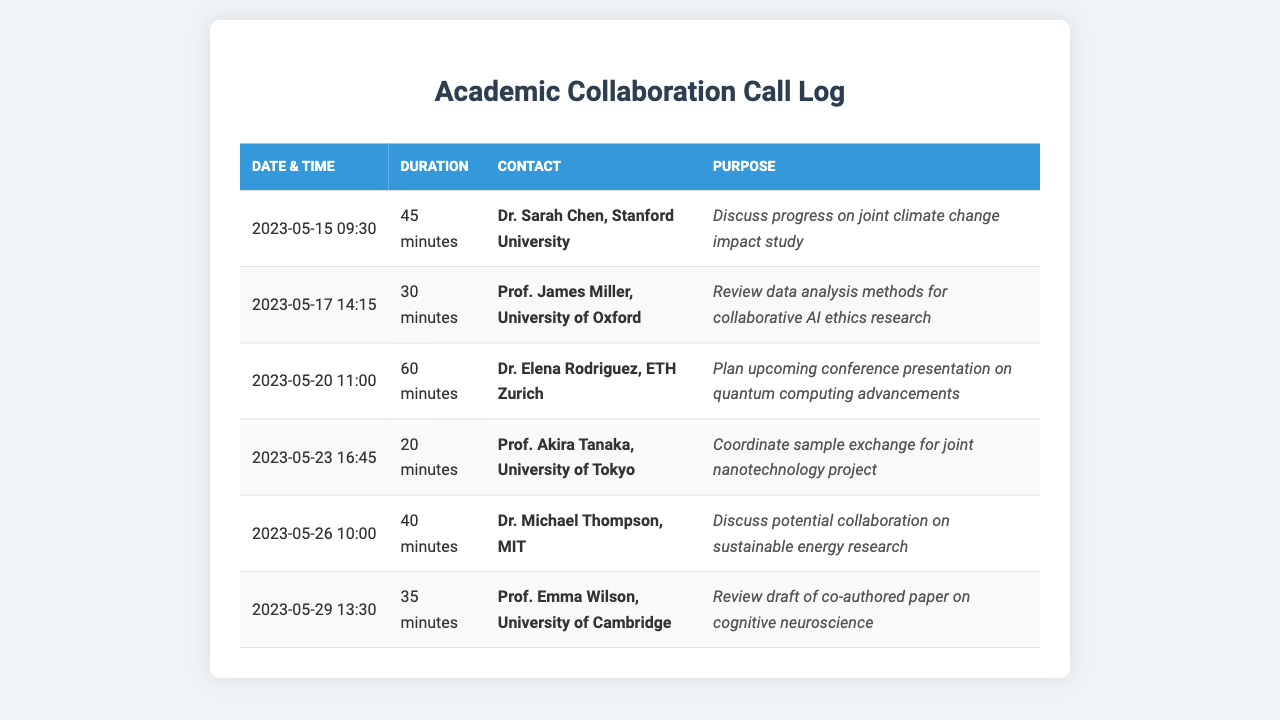What was the date of the call with Dr. Sarah Chen? The call with Dr. Sarah Chen occurred on May 15, 2023.
Answer: May 15, 2023 How long did the call with Prof. James Miller last? The call with Prof. James Miller lasted for 30 minutes.
Answer: 30 minutes Who was contacted regarding the quantum computing presentation? Dr. Elena Rodriguez was contacted regarding the conference presentation on quantum computing advancements.
Answer: Dr. Elena Rodriguez What was the purpose of the call with Prof. Akira Tanaka? The purpose of the call with Prof. Akira Tanaka was to coordinate sample exchange for a joint nanotechnology project.
Answer: Coordinate sample exchange for joint nanotechnology project Which university does Dr. Michael Thompson belong to? Dr. Michael Thompson is from MIT.
Answer: MIT How many calls are listed in total? There are six calls listed in total.
Answer: 6 What is the earliest call date recorded? The earliest call date recorded is May 15, 2023.
Answer: May 15, 2023 Which collaborator was involved in reviewing the draft of a co-authored paper? Prof. Emma Wilson was involved in reviewing the draft of the co-authored paper on cognitive neuroscience.
Answer: Prof. Emma Wilson What is the common purpose of the calls listed? The common purpose of the calls is discussing various research collaborations.
Answer: Discussing various research collaborations 